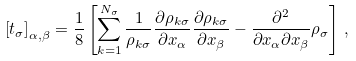<formula> <loc_0><loc_0><loc_500><loc_500>\left [ t _ { \sigma } \right ] _ { \alpha , \beta } = \frac { 1 } { 8 } \left [ \sum _ { k = 1 } ^ { N _ { \sigma } } \frac { 1 } { \rho _ { k \sigma } } \frac { \partial \rho _ { k \sigma } } { \partial x _ { \alpha } } \frac { \partial \rho _ { k \sigma } } { \partial x _ { \beta } } - \frac { \partial ^ { 2 } } { \partial x _ { \alpha } \partial x _ { \beta } } \rho _ { \sigma } \right ] \, ,</formula> 